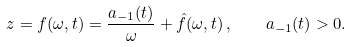<formula> <loc_0><loc_0><loc_500><loc_500>z = f ( \omega , t ) = \frac { a _ { - 1 } ( t ) } { \omega } + \hat { f } ( \omega , t ) \, , \quad a _ { - 1 } ( t ) > 0 .</formula> 